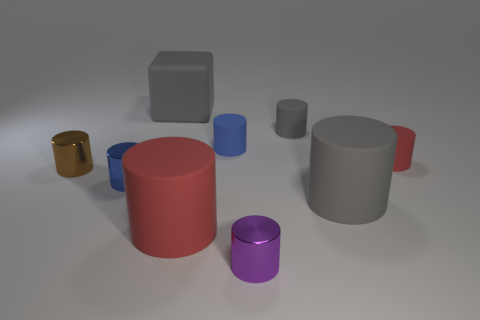What number of objects are tiny objects right of the large red matte object or small red matte things?
Your answer should be very brief. 4. Is there a small gray matte thing of the same shape as the brown shiny thing?
Provide a short and direct response. Yes. Is the number of big gray cylinders behind the blue metal object the same as the number of purple spheres?
Ensure brevity in your answer.  Yes. The small thing that is the same color as the cube is what shape?
Provide a short and direct response. Cylinder. How many red things are the same size as the brown metal cylinder?
Ensure brevity in your answer.  1. There is a small brown cylinder; how many small purple shiny cylinders are behind it?
Your answer should be very brief. 0. What is the material of the blue thing that is in front of the small brown cylinder that is in front of the big rubber block?
Provide a succinct answer. Metal. Is there a large cylinder of the same color as the big rubber cube?
Offer a very short reply. Yes. There is a blue object that is the same material as the large gray cube; what is its size?
Your response must be concise. Small. Is there any other thing that is the same color as the big matte cube?
Offer a terse response. Yes. 